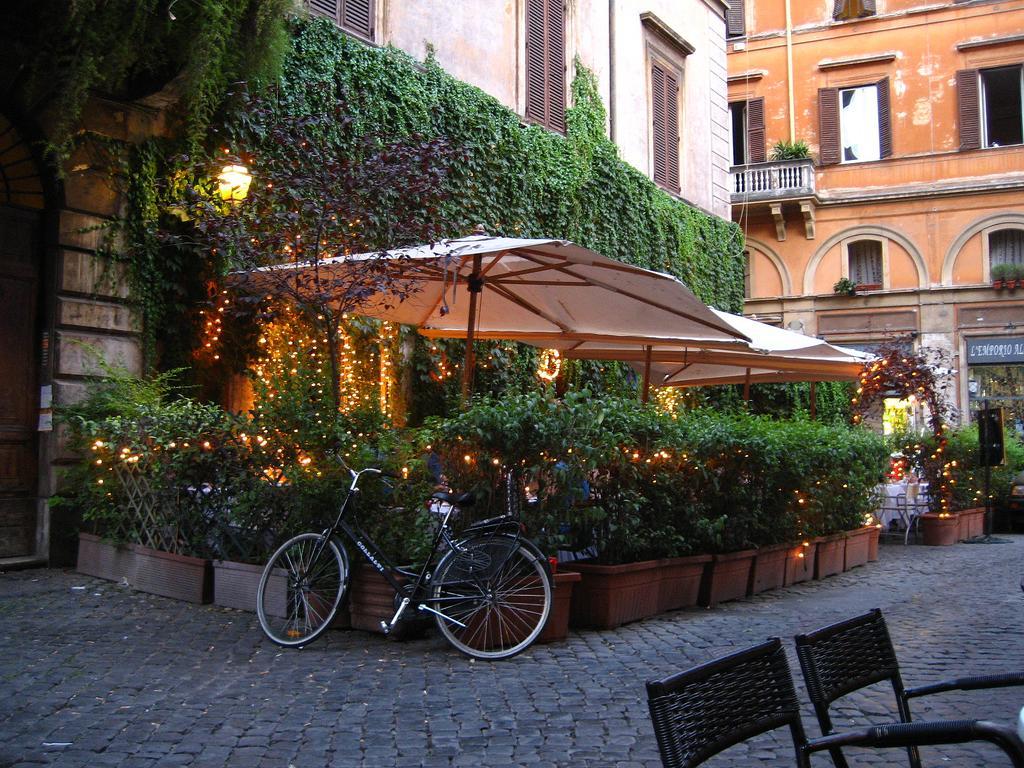In one or two sentences, can you explain what this image depicts? In this picture i could see some creepers from the building creeping along the floor and there is an umbrella and some plants, plant pots and walking path and a cycle leaning on the pots and some chairs which are black in color. In the right corner there is a building in orange color with windows opened and some shops near by. 